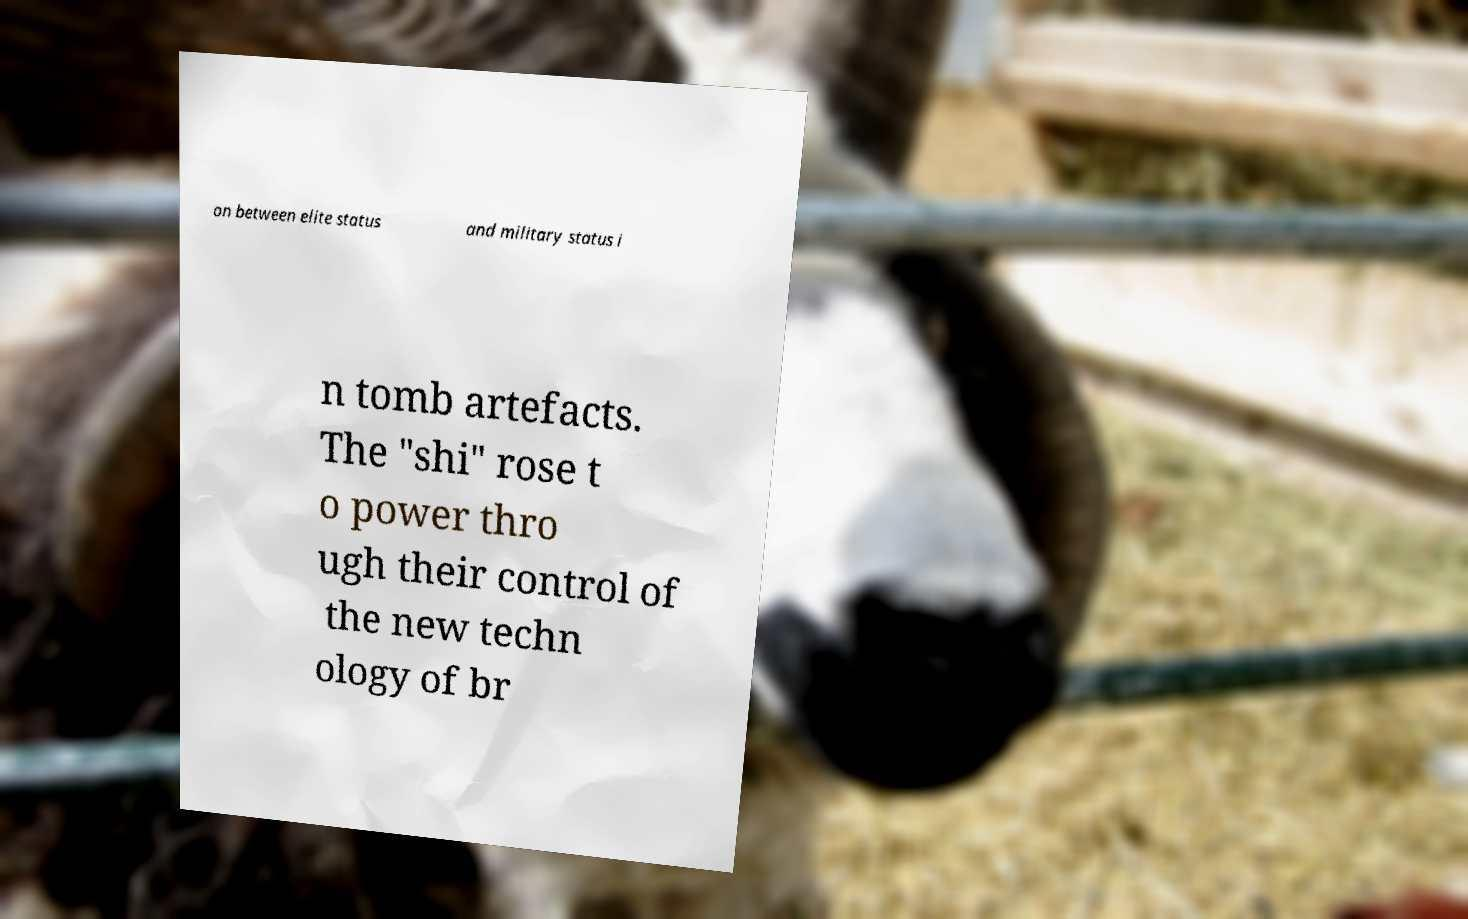What messages or text are displayed in this image? I need them in a readable, typed format. on between elite status and military status i n tomb artefacts. The "shi" rose t o power thro ugh their control of the new techn ology of br 